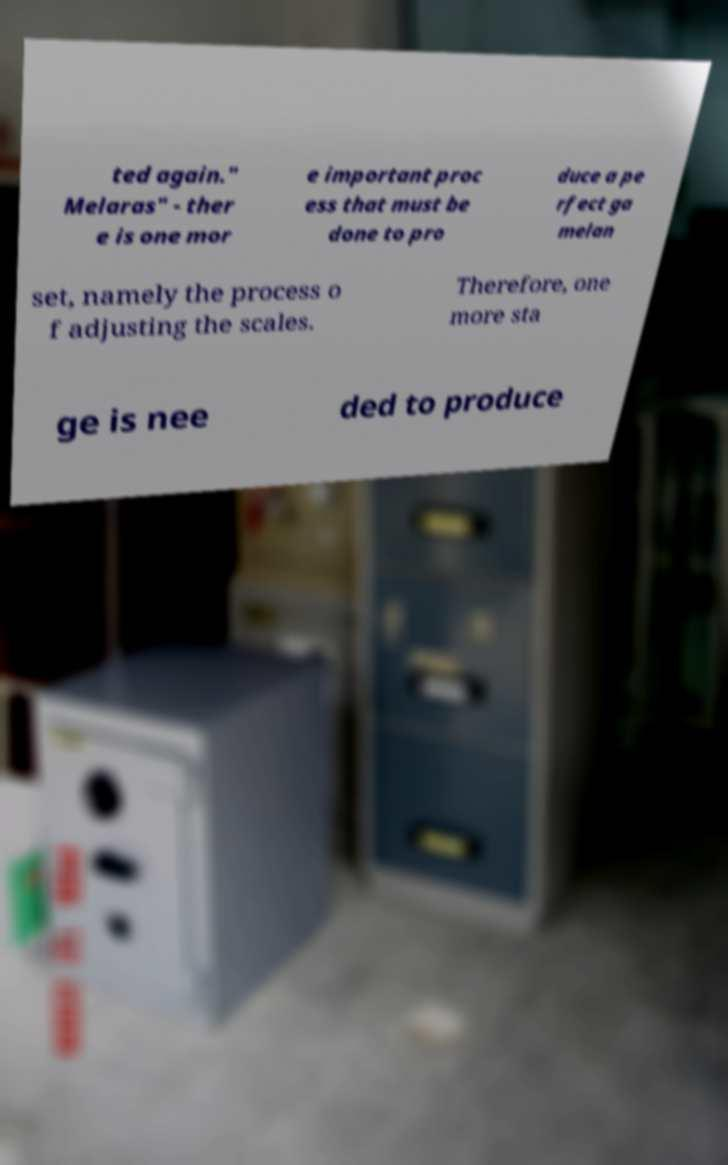Can you accurately transcribe the text from the provided image for me? ted again." Melaras" - ther e is one mor e important proc ess that must be done to pro duce a pe rfect ga melan set, namely the process o f adjusting the scales. Therefore, one more sta ge is nee ded to produce 